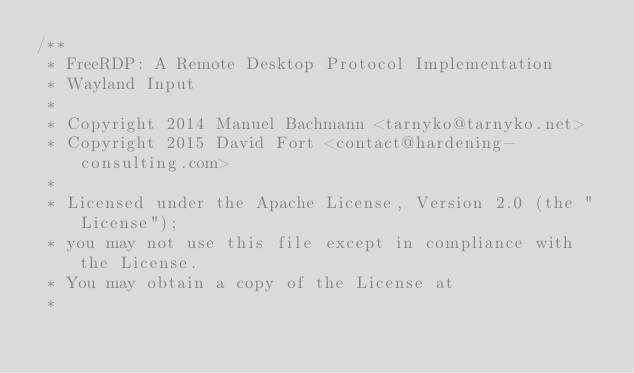Convert code to text. <code><loc_0><loc_0><loc_500><loc_500><_C_>/**
 * FreeRDP: A Remote Desktop Protocol Implementation
 * Wayland Input
 *
 * Copyright 2014 Manuel Bachmann <tarnyko@tarnyko.net>
 * Copyright 2015 David Fort <contact@hardening-consulting.com>
 *
 * Licensed under the Apache License, Version 2.0 (the "License");
 * you may not use this file except in compliance with the License.
 * You may obtain a copy of the License at
 *</code> 